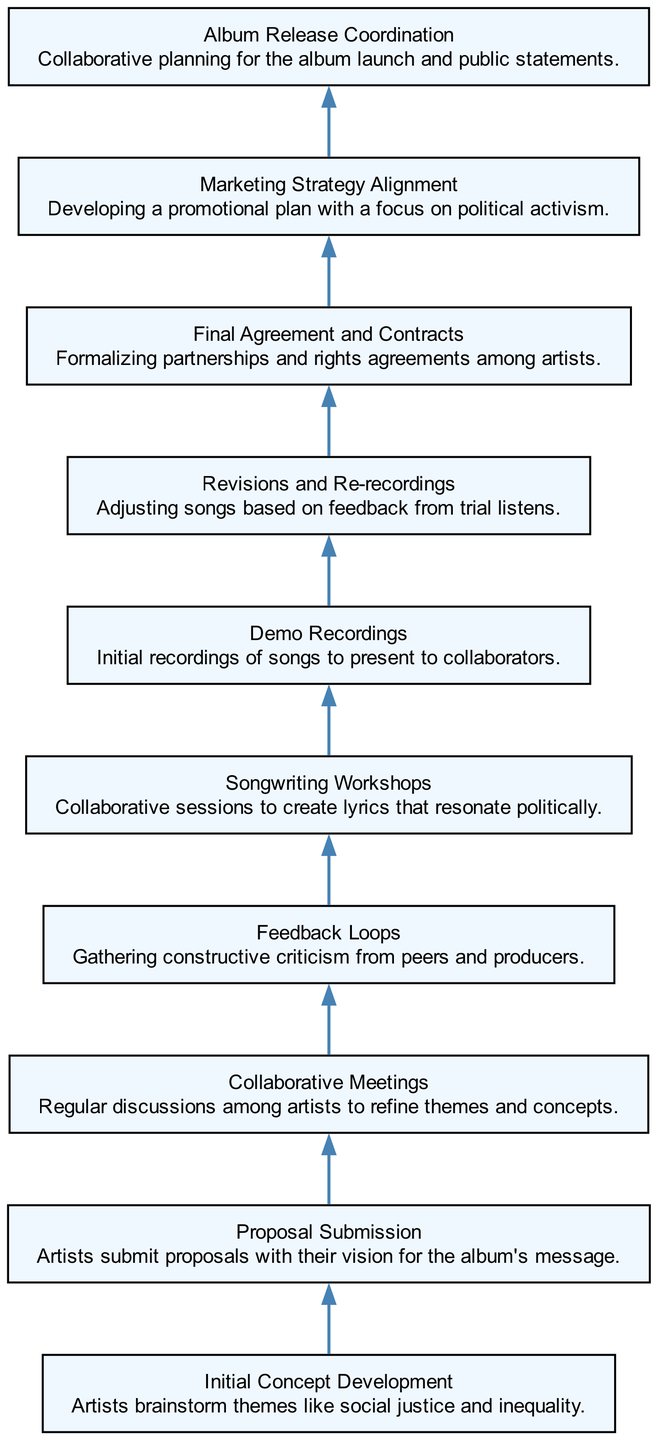What is the first step in the collaboration process? The first step, labeled as "Initial Concept Development," involves artists brainstorming themes like social justice and inequality.
Answer: Initial Concept Development How many total nodes are present in the diagram? By counting all the unique steps in the collaboration process, we see there are 10 nodes listed in the diagram.
Answer: 10 What step follows "Demo Recordings" in the flow? The step that comes after "Demo Recordings" is "Revisions and Re-recordings," indicating adjustments made based on feedback.
Answer: Revisions and Re-recordings Which step directly leads to "Final Agreement and Contracts"? The step that leads directly to "Final Agreement and Contracts" is "Revisions and Re-recordings," as this indicates that revisions may lead to finalizing partnerships.
Answer: Revisions and Re-recordings In what order does "Collaborative Meetings" appear in relation to "Feedback Loops"? "Collaborative Meetings" appears before "Feedback Loops," indicating that discussion leads to solicitation of feedback from peers and producers.
Answer: Before What is the last step in the diagram? The last step, according to the flow of the diagram, is "Album Release Coordination," representing the final planning stage for the album launch.
Answer: Album Release Coordination Which process step involves creating politically resonant lyrics? The step focused on creating lyrics that resonate politically is "Songwriting Workshops," where collaboration occurs to build those lyrics.
Answer: Songwriting Workshops How does the flow relate "Proposal Submission" to "Collaborative Meetings"? "Proposal Submission" leads into "Collaborative Meetings," as proposals would typically be discussed and revised during these meetings.
Answer: Leads into What is the focus of the "Marketing Strategy Alignment"? The focus of "Marketing Strategy Alignment" is on developing a promotional plan with a specific emphasis on political activism.
Answer: Political activism 